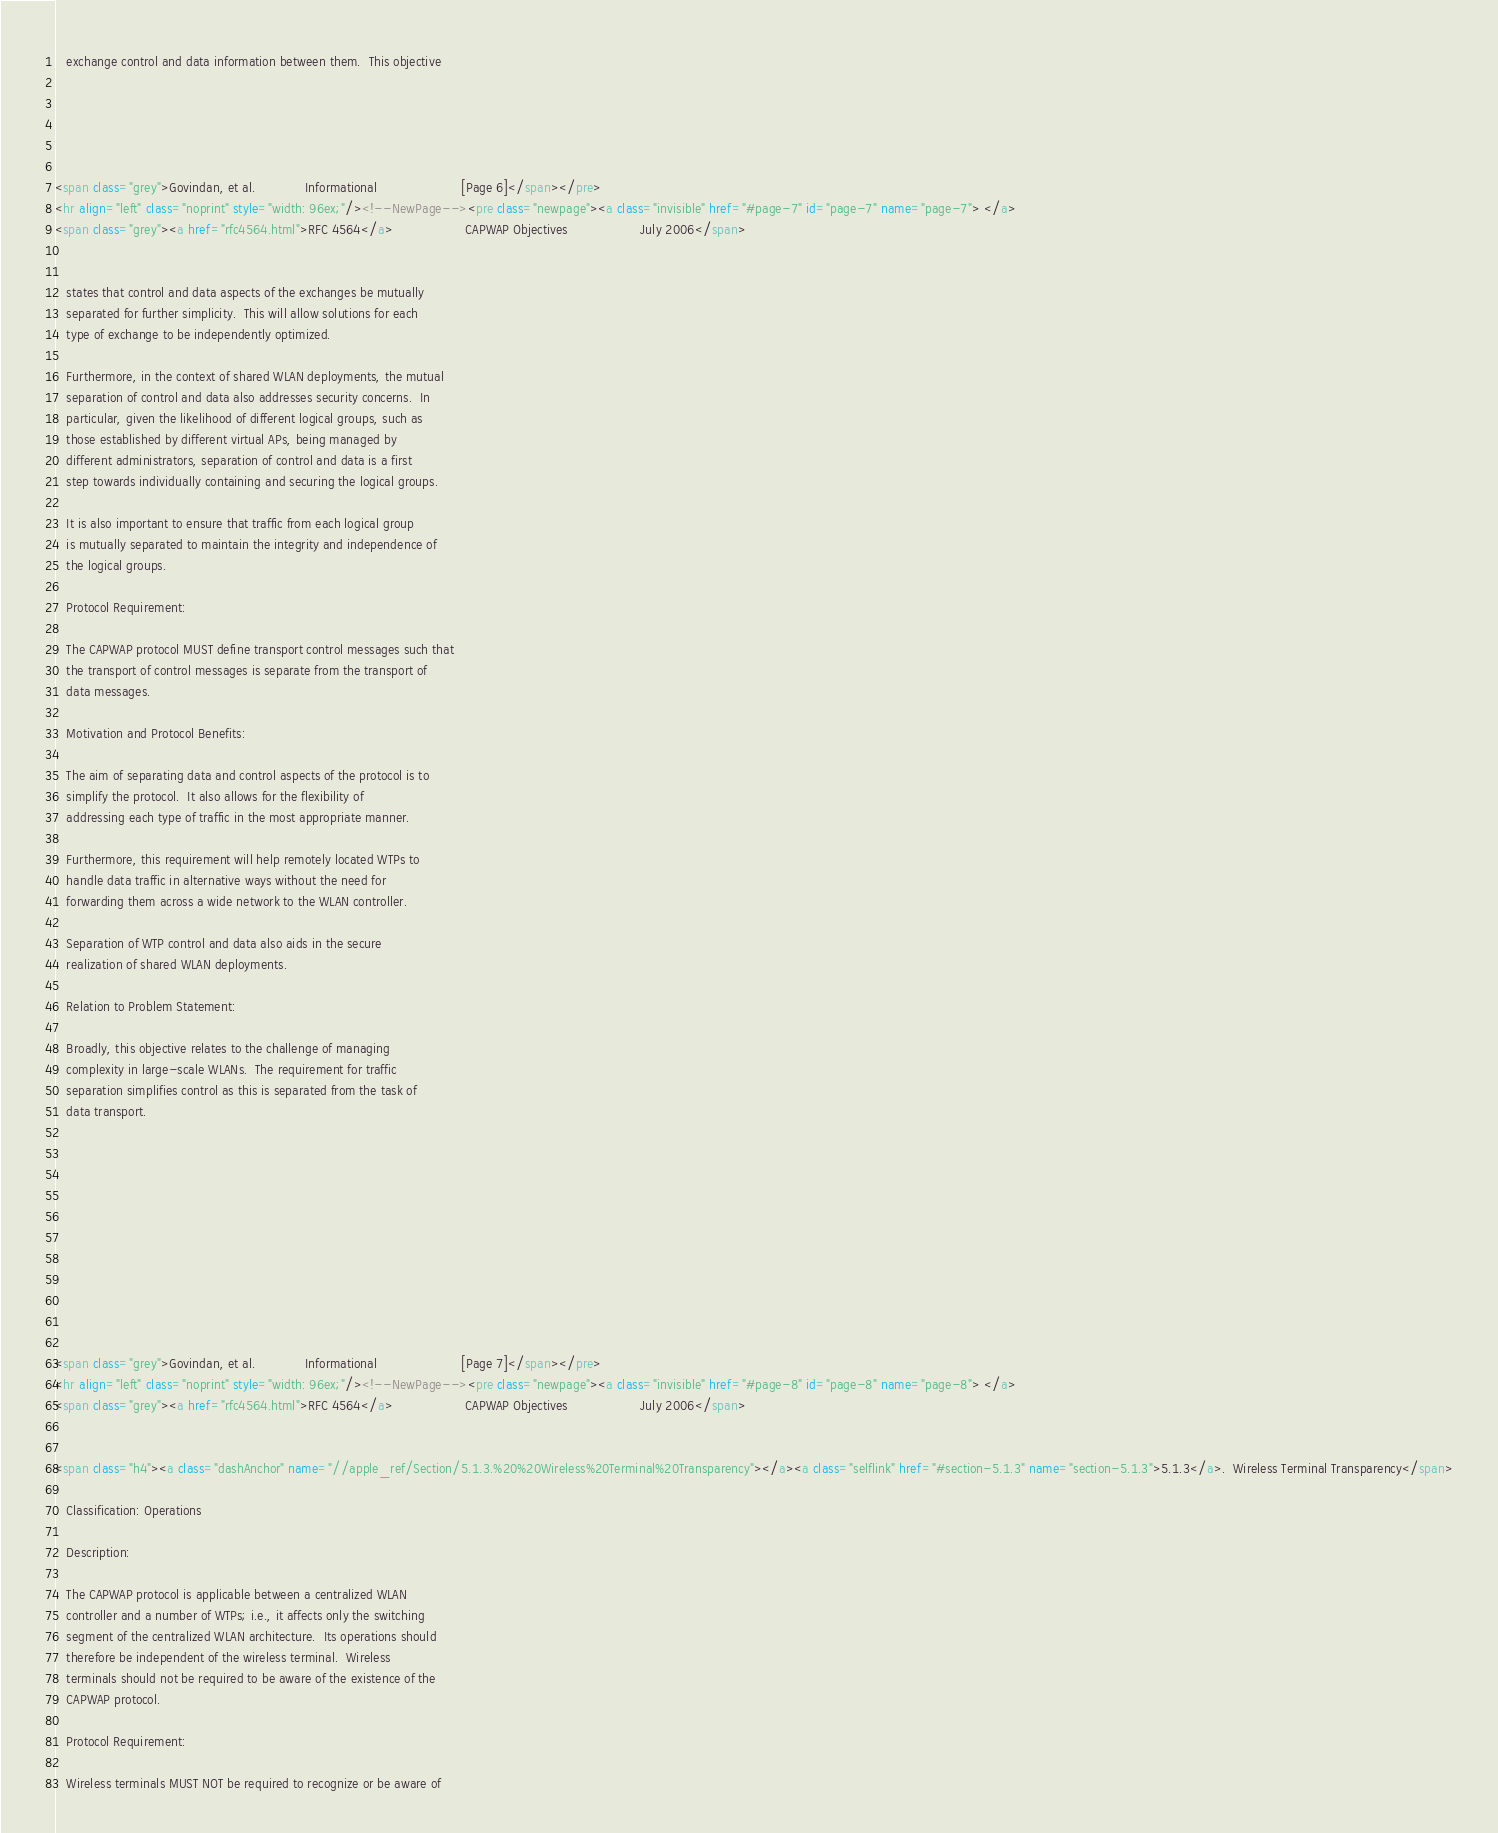Convert code to text. <code><loc_0><loc_0><loc_500><loc_500><_HTML_>   exchange control and data information between them.  This objective





<span class="grey">Govindan, et al.             Informational                      [Page 6]</span></pre>
<hr align="left" class="noprint" style="width: 96ex;"/><!--NewPage--><pre class="newpage"><a class="invisible" href="#page-7" id="page-7" name="page-7"> </a>
<span class="grey"><a href="rfc4564.html">RFC 4564</a>                   CAPWAP Objectives                   July 2006</span>


   states that control and data aspects of the exchanges be mutually
   separated for further simplicity.  This will allow solutions for each
   type of exchange to be independently optimized.

   Furthermore, in the context of shared WLAN deployments, the mutual
   separation of control and data also addresses security concerns.  In
   particular, given the likelihood of different logical groups, such as
   those established by different virtual APs, being managed by
   different administrators, separation of control and data is a first
   step towards individually containing and securing the logical groups.

   It is also important to ensure that traffic from each logical group
   is mutually separated to maintain the integrity and independence of
   the logical groups.

   Protocol Requirement:

   The CAPWAP protocol MUST define transport control messages such that
   the transport of control messages is separate from the transport of
   data messages.

   Motivation and Protocol Benefits:

   The aim of separating data and control aspects of the protocol is to
   simplify the protocol.  It also allows for the flexibility of
   addressing each type of traffic in the most appropriate manner.

   Furthermore, this requirement will help remotely located WTPs to
   handle data traffic in alternative ways without the need for
   forwarding them across a wide network to the WLAN controller.

   Separation of WTP control and data also aids in the secure
   realization of shared WLAN deployments.

   Relation to Problem Statement:

   Broadly, this objective relates to the challenge of managing
   complexity in large-scale WLANs.  The requirement for traffic
   separation simplifies control as this is separated from the task of
   data transport.











<span class="grey">Govindan, et al.             Informational                      [Page 7]</span></pre>
<hr align="left" class="noprint" style="width: 96ex;"/><!--NewPage--><pre class="newpage"><a class="invisible" href="#page-8" id="page-8" name="page-8"> </a>
<span class="grey"><a href="rfc4564.html">RFC 4564</a>                   CAPWAP Objectives                   July 2006</span>


<span class="h4"><a class="dashAnchor" name="//apple_ref/Section/5.1.3.%20%20Wireless%20Terminal%20Transparency"></a><a class="selflink" href="#section-5.1.3" name="section-5.1.3">5.1.3</a>.  Wireless Terminal Transparency</span>

   Classification: Operations

   Description:

   The CAPWAP protocol is applicable between a centralized WLAN
   controller and a number of WTPs; i.e., it affects only the switching
   segment of the centralized WLAN architecture.  Its operations should
   therefore be independent of the wireless terminal.  Wireless
   terminals should not be required to be aware of the existence of the
   CAPWAP protocol.

   Protocol Requirement:

   Wireless terminals MUST NOT be required to recognize or be aware of</code> 